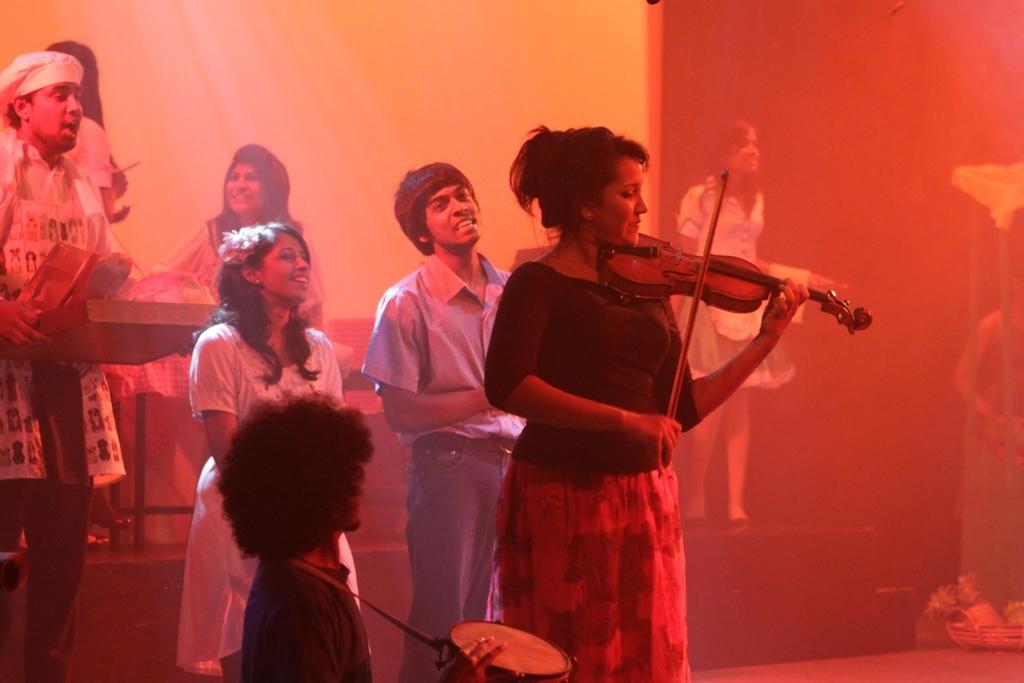Describe this image in one or two sentences. In the image we can see there are lot of people who are standing and a woman is holding violin in her hand and the people are looking at each other. 